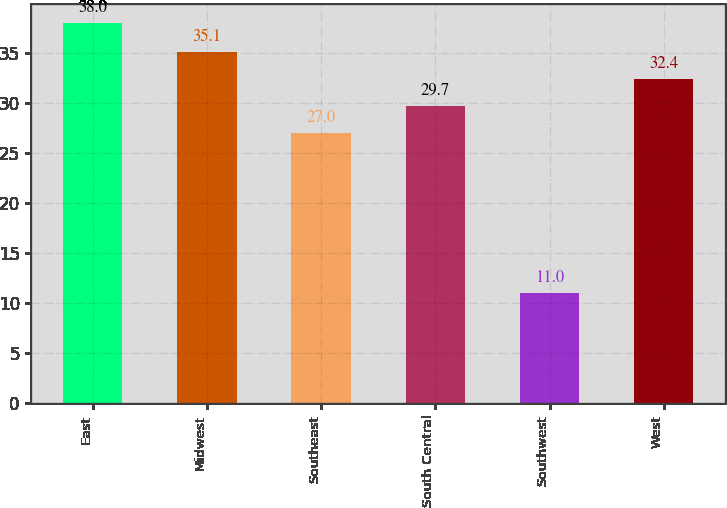Convert chart to OTSL. <chart><loc_0><loc_0><loc_500><loc_500><bar_chart><fcel>East<fcel>Midwest<fcel>Southeast<fcel>South Central<fcel>Southwest<fcel>West<nl><fcel>38<fcel>35.1<fcel>27<fcel>29.7<fcel>11<fcel>32.4<nl></chart> 